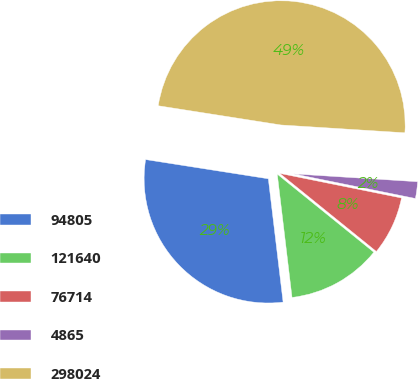Convert chart. <chart><loc_0><loc_0><loc_500><loc_500><pie_chart><fcel>94805<fcel>121640<fcel>76714<fcel>4865<fcel>298024<nl><fcel>29.37%<fcel>12.28%<fcel>7.65%<fcel>2.17%<fcel>48.53%<nl></chart> 